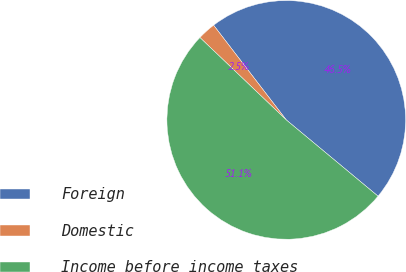Convert chart. <chart><loc_0><loc_0><loc_500><loc_500><pie_chart><fcel>Foreign<fcel>Domestic<fcel>Income before income taxes<nl><fcel>46.45%<fcel>2.46%<fcel>51.09%<nl></chart> 